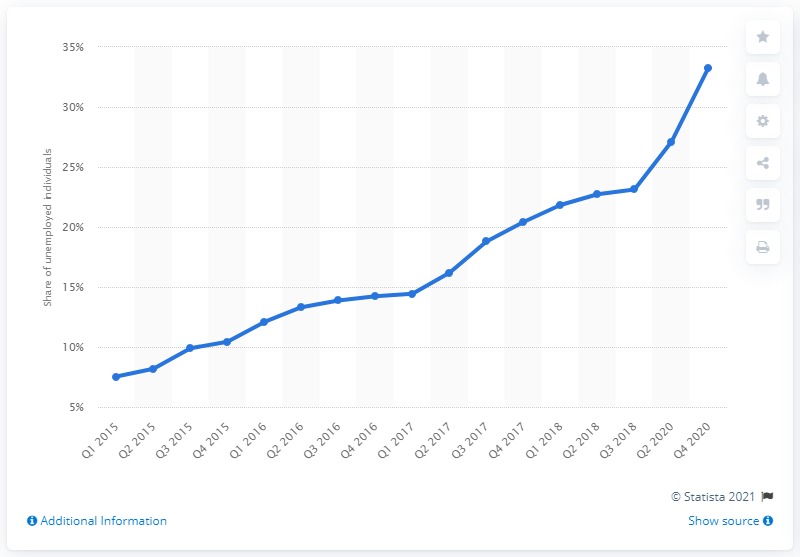Highlight a few significant elements in this photo. In the fourth quarter of 2020, Nigeria's unemployment rate was 33.28%. The unemployment rate in Nigeria increased by 33.28% between 2015 and 2020. 